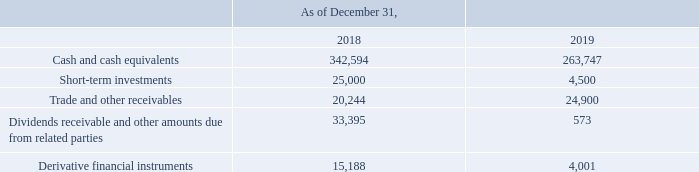GasLog Ltd. and its Subsidiaries
Notes to the consolidated financial statements (Continued)
For the years ended December 31, 2017, 2018 and 2019
(All amounts expressed in thousands of U.S. Dollars, except share and per share data)
Credit risk
Credit risk is the risk that a counterparty will fail to discharge its obligations and cause a financial loss and arises from cash and cash equivalents, short-term investments, favorable derivative financial instruments and deposits with banks and financial institutions, as well as credit exposures to customers, including trade and other receivables, dividends receivable and other amounts due from related parties. The Group is exposed to credit risk in the event of non-performance by any of its counterparties. To limit this risk, the Group currently deals primarily with financial institutions and customers with high credit ratings.
For the year ended December 31, 2019, 70.0% of the Group’s revenue was earned from Shell (December 31, 2018 and December 31, 2017, 74.2% and 92.6%, respectively) and accounts receivable were not collateralized; however, management believes that the credit risk is partially offset by the creditworthiness of the Group’s counterparties. BG Group was acquired by Shell on February 15, 2016. This acquisition does not impact the contractual obligations under the existing charter party agreements. The Group did not experience significant credit losses on its accounts receivable portfolio during the three years ended December 31, 2019. The carrying amount of financial assets recorded in the consolidated financial statements represents the Group’s maximum exposure to credit risk. Management monitors exposure to credit risk, and they believe that there is no substantial credit risk arising from the Group’s counterparties.
The credit risk on liquid funds and derivative financial instruments is limited because the counterparties are banks with high credit ratings assigned by international credit-rating agencies.
How does the Group limit its exposure to credit risk? To limit this risk, the group currently deals primarily with financial institutions and customers with high credit ratings. When did Shell acquire BG Group? February 15, 2016. What are the components subjected to credit risk? Cash and cash equivalents, short-term investments, trade and other receivables, dividends receivable and other amounts due from related parties, derivative financial instruments. Which year was the cash and cash equivalents higher? 342,594 > 263,747
Answer: 2018. What was the change in short-term investments from 2018 to 2019?
Answer scale should be: thousand. 4,500 - 25,000 
Answer: -20500. What was the percentage change in derivative financial instruments from 2018 to 2019?
Answer scale should be: percent. (4,001 - 15,188)/15,188 
Answer: -73.66. 